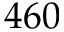Convert formula to latex. <formula><loc_0><loc_0><loc_500><loc_500>4 6 0</formula> 